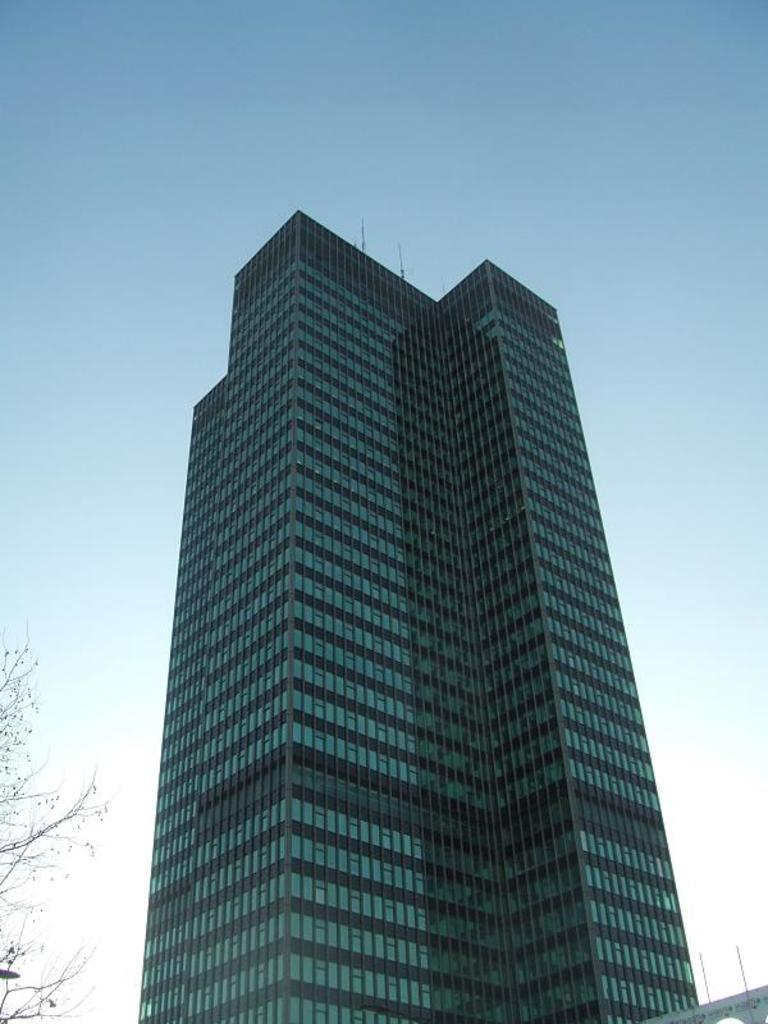In one or two sentences, can you explain what this image depicts? In this image we can see the building. We can also see the tree. In the background there is sky. 